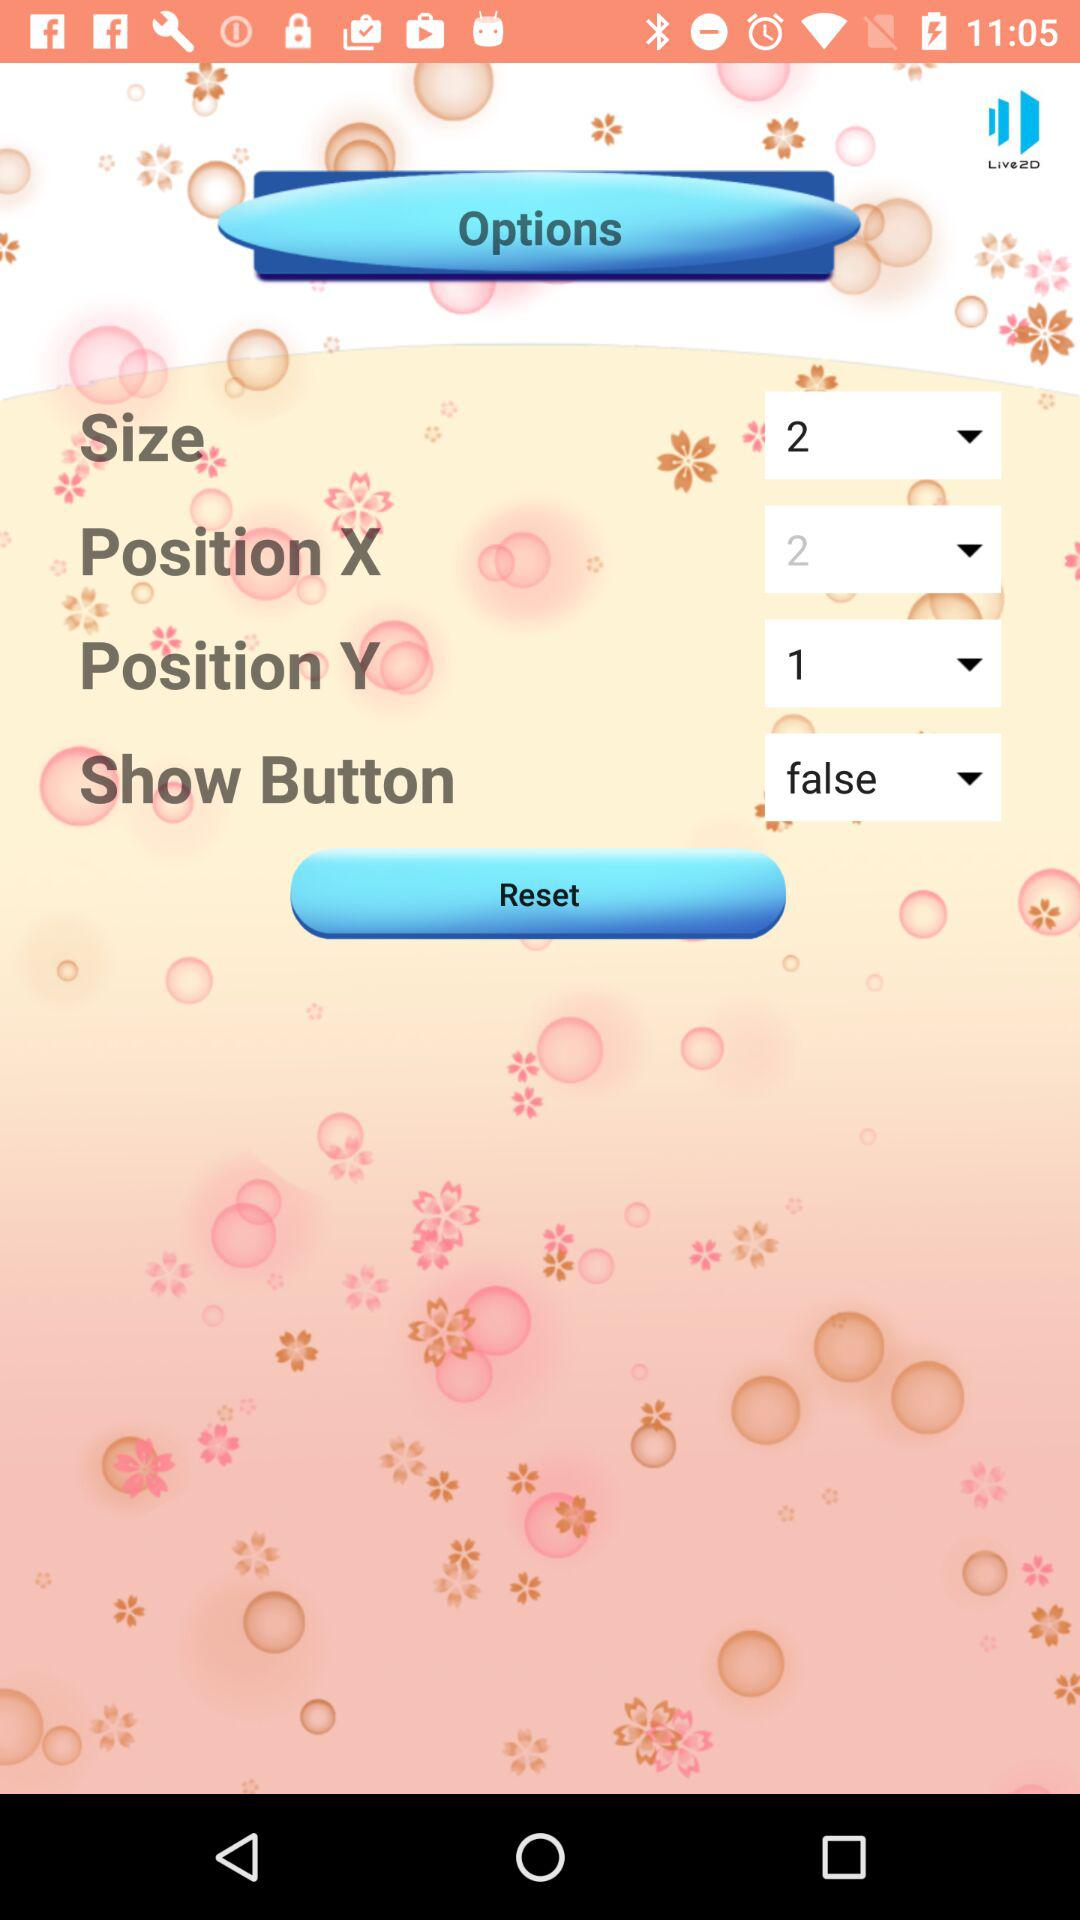How many options are there in the options menu?
Answer the question using a single word or phrase. 4 